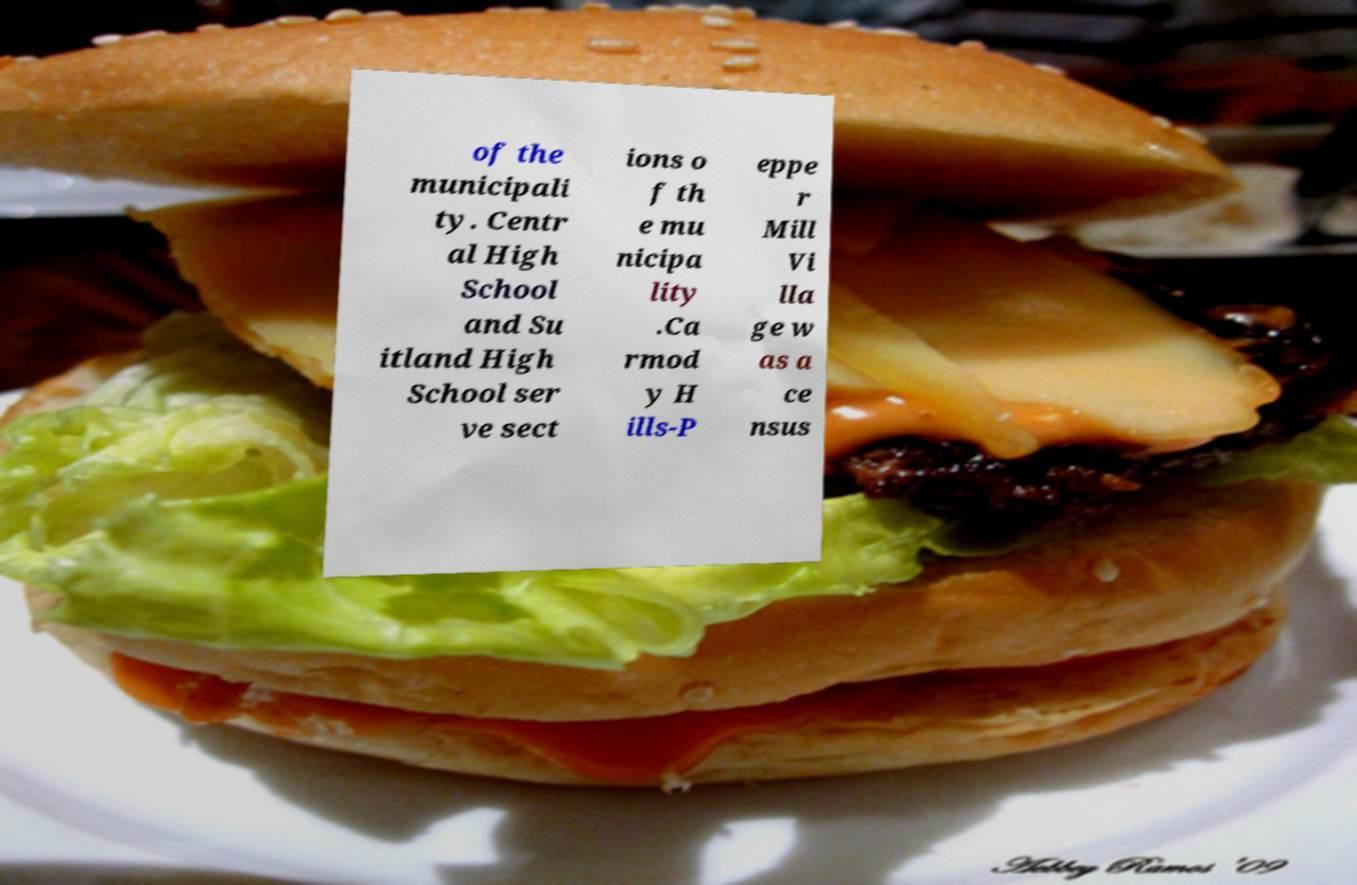What messages or text are displayed in this image? I need them in a readable, typed format. of the municipali ty. Centr al High School and Su itland High School ser ve sect ions o f th e mu nicipa lity .Ca rmod y H ills-P eppe r Mill Vi lla ge w as a ce nsus 